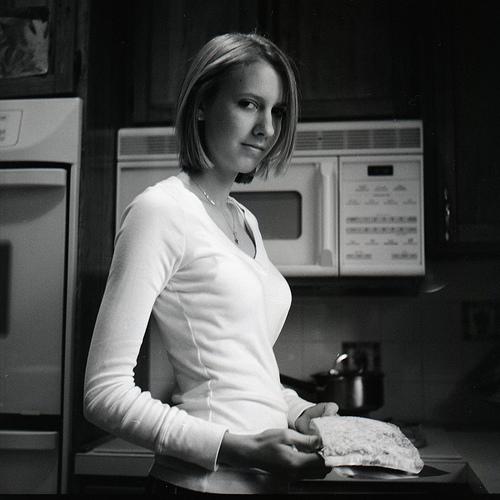What room is the lady in?
Quick response, please. Kitchen. Is someone wearing glasses?
Short answer required. No. Is this lady wearing a necklace?
Write a very short answer. Yes. Is there a cat on this girls shirt?
Give a very brief answer. No. What food item is the girl eating?
Write a very short answer. Pizza. Is she getting her hair dryer?
Give a very brief answer. No. How is the girl's hair fashioned?
Concise answer only. Short. Is the oven in a normal place?
Concise answer only. Yes. Is the girl wearing a bracelet?
Be succinct. No. What direction is everyone looking?
Write a very short answer. Right. 